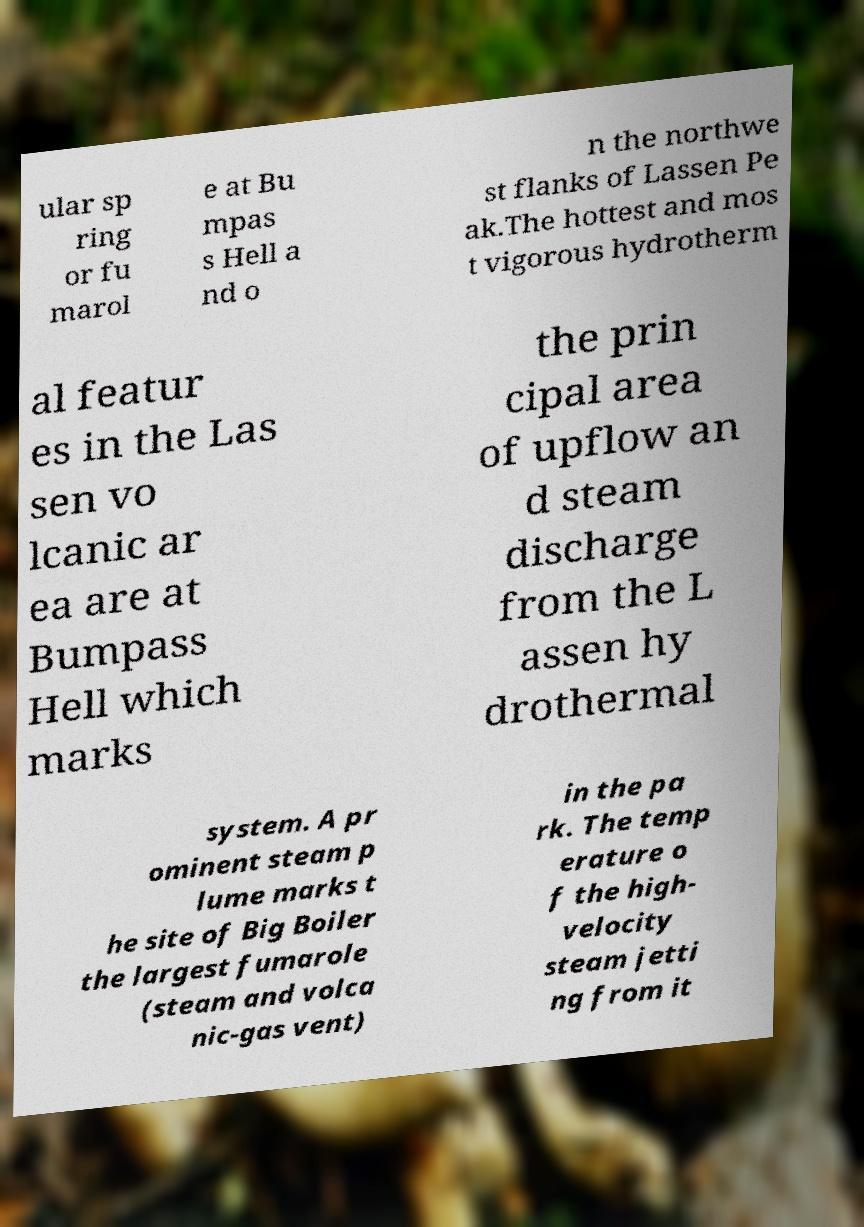What messages or text are displayed in this image? I need them in a readable, typed format. ular sp ring or fu marol e at Bu mpas s Hell a nd o n the northwe st flanks of Lassen Pe ak.The hottest and mos t vigorous hydrotherm al featur es in the Las sen vo lcanic ar ea are at Bumpass Hell which marks the prin cipal area of upflow an d steam discharge from the L assen hy drothermal system. A pr ominent steam p lume marks t he site of Big Boiler the largest fumarole (steam and volca nic-gas vent) in the pa rk. The temp erature o f the high- velocity steam jetti ng from it 